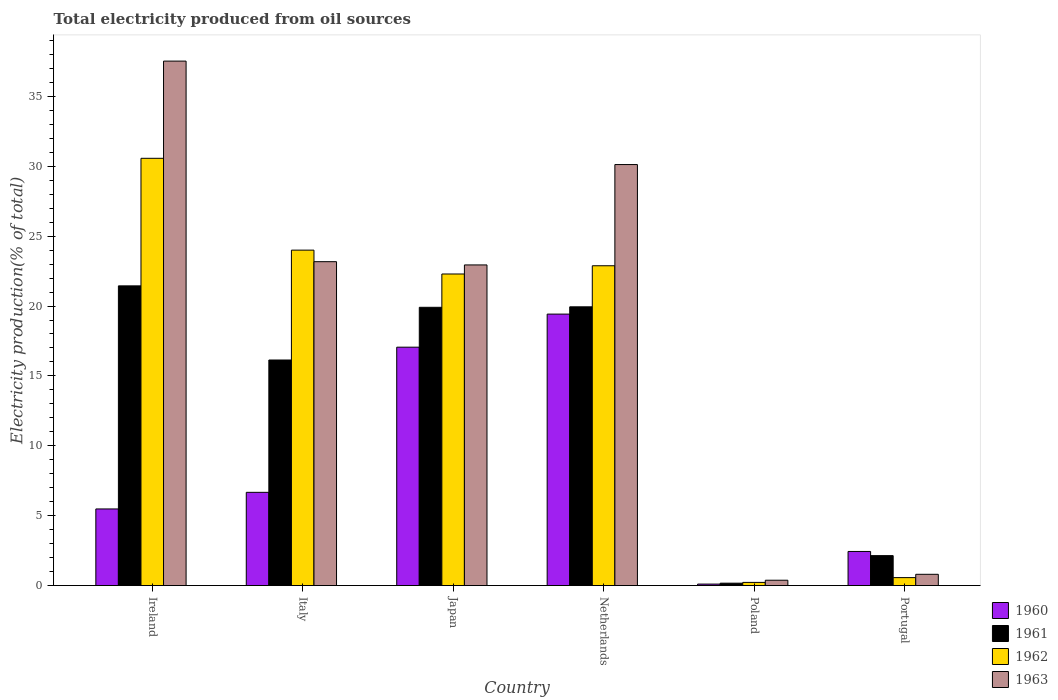How many different coloured bars are there?
Give a very brief answer. 4. Are the number of bars per tick equal to the number of legend labels?
Keep it short and to the point. Yes. Are the number of bars on each tick of the X-axis equal?
Ensure brevity in your answer.  Yes. How many bars are there on the 3rd tick from the right?
Keep it short and to the point. 4. In how many cases, is the number of bars for a given country not equal to the number of legend labels?
Your response must be concise. 0. What is the total electricity produced in 1960 in Poland?
Make the answer very short. 0.11. Across all countries, what is the maximum total electricity produced in 1960?
Provide a succinct answer. 19.42. Across all countries, what is the minimum total electricity produced in 1962?
Keep it short and to the point. 0.23. In which country was the total electricity produced in 1960 minimum?
Provide a short and direct response. Poland. What is the total total electricity produced in 1960 in the graph?
Offer a very short reply. 51.18. What is the difference between the total electricity produced in 1960 in Italy and that in Portugal?
Keep it short and to the point. 4.23. What is the difference between the total electricity produced in 1962 in Italy and the total electricity produced in 1960 in Poland?
Give a very brief answer. 23.89. What is the average total electricity produced in 1963 per country?
Give a very brief answer. 19.16. What is the difference between the total electricity produced of/in 1962 and total electricity produced of/in 1960 in Italy?
Provide a short and direct response. 17.33. What is the ratio of the total electricity produced in 1962 in Ireland to that in Poland?
Keep it short and to the point. 135.14. What is the difference between the highest and the second highest total electricity produced in 1963?
Keep it short and to the point. 7.4. What is the difference between the highest and the lowest total electricity produced in 1961?
Ensure brevity in your answer.  21.27. In how many countries, is the total electricity produced in 1963 greater than the average total electricity produced in 1963 taken over all countries?
Keep it short and to the point. 4. Is it the case that in every country, the sum of the total electricity produced in 1963 and total electricity produced in 1961 is greater than the sum of total electricity produced in 1960 and total electricity produced in 1962?
Your answer should be very brief. No. What does the 3rd bar from the left in Poland represents?
Give a very brief answer. 1962. Is it the case that in every country, the sum of the total electricity produced in 1962 and total electricity produced in 1961 is greater than the total electricity produced in 1963?
Offer a very short reply. Yes. How many bars are there?
Provide a succinct answer. 24. How many countries are there in the graph?
Offer a very short reply. 6. What is the difference between two consecutive major ticks on the Y-axis?
Make the answer very short. 5. Are the values on the major ticks of Y-axis written in scientific E-notation?
Your answer should be compact. No. Does the graph contain any zero values?
Your answer should be compact. No. Where does the legend appear in the graph?
Provide a succinct answer. Bottom right. How are the legend labels stacked?
Your response must be concise. Vertical. What is the title of the graph?
Offer a terse response. Total electricity produced from oil sources. Does "2000" appear as one of the legend labels in the graph?
Offer a very short reply. No. What is the label or title of the X-axis?
Give a very brief answer. Country. What is the Electricity production(% of total) of 1960 in Ireland?
Keep it short and to the point. 5.48. What is the Electricity production(% of total) of 1961 in Ireland?
Your response must be concise. 21.44. What is the Electricity production(% of total) in 1962 in Ireland?
Your answer should be very brief. 30.57. What is the Electricity production(% of total) of 1963 in Ireland?
Ensure brevity in your answer.  37.53. What is the Electricity production(% of total) of 1960 in Italy?
Your answer should be compact. 6.67. What is the Electricity production(% of total) of 1961 in Italy?
Offer a terse response. 16.14. What is the Electricity production(% of total) in 1962 in Italy?
Make the answer very short. 24. What is the Electricity production(% of total) of 1963 in Italy?
Provide a short and direct response. 23.17. What is the Electricity production(% of total) in 1960 in Japan?
Offer a very short reply. 17.06. What is the Electricity production(% of total) in 1961 in Japan?
Ensure brevity in your answer.  19.91. What is the Electricity production(% of total) in 1962 in Japan?
Make the answer very short. 22.29. What is the Electricity production(% of total) of 1963 in Japan?
Provide a succinct answer. 22.94. What is the Electricity production(% of total) in 1960 in Netherlands?
Provide a short and direct response. 19.42. What is the Electricity production(% of total) of 1961 in Netherlands?
Your answer should be compact. 19.94. What is the Electricity production(% of total) of 1962 in Netherlands?
Ensure brevity in your answer.  22.88. What is the Electricity production(% of total) of 1963 in Netherlands?
Provide a succinct answer. 30.12. What is the Electricity production(% of total) of 1960 in Poland?
Your answer should be compact. 0.11. What is the Electricity production(% of total) in 1961 in Poland?
Provide a short and direct response. 0.17. What is the Electricity production(% of total) of 1962 in Poland?
Your answer should be very brief. 0.23. What is the Electricity production(% of total) in 1963 in Poland?
Offer a very short reply. 0.38. What is the Electricity production(% of total) in 1960 in Portugal?
Your answer should be very brief. 2.44. What is the Electricity production(% of total) in 1961 in Portugal?
Provide a succinct answer. 2.14. What is the Electricity production(% of total) of 1962 in Portugal?
Make the answer very short. 0.57. What is the Electricity production(% of total) of 1963 in Portugal?
Give a very brief answer. 0.81. Across all countries, what is the maximum Electricity production(% of total) of 1960?
Provide a short and direct response. 19.42. Across all countries, what is the maximum Electricity production(% of total) in 1961?
Ensure brevity in your answer.  21.44. Across all countries, what is the maximum Electricity production(% of total) of 1962?
Your answer should be very brief. 30.57. Across all countries, what is the maximum Electricity production(% of total) in 1963?
Give a very brief answer. 37.53. Across all countries, what is the minimum Electricity production(% of total) in 1960?
Your answer should be very brief. 0.11. Across all countries, what is the minimum Electricity production(% of total) in 1961?
Give a very brief answer. 0.17. Across all countries, what is the minimum Electricity production(% of total) in 1962?
Offer a very short reply. 0.23. Across all countries, what is the minimum Electricity production(% of total) in 1963?
Keep it short and to the point. 0.38. What is the total Electricity production(% of total) of 1960 in the graph?
Your response must be concise. 51.18. What is the total Electricity production(% of total) in 1961 in the graph?
Your answer should be very brief. 79.75. What is the total Electricity production(% of total) of 1962 in the graph?
Your response must be concise. 100.54. What is the total Electricity production(% of total) in 1963 in the graph?
Offer a very short reply. 114.95. What is the difference between the Electricity production(% of total) of 1960 in Ireland and that in Italy?
Ensure brevity in your answer.  -1.19. What is the difference between the Electricity production(% of total) in 1961 in Ireland and that in Italy?
Your answer should be very brief. 5.3. What is the difference between the Electricity production(% of total) of 1962 in Ireland and that in Italy?
Provide a short and direct response. 6.57. What is the difference between the Electricity production(% of total) of 1963 in Ireland and that in Italy?
Keep it short and to the point. 14.35. What is the difference between the Electricity production(% of total) in 1960 in Ireland and that in Japan?
Your response must be concise. -11.57. What is the difference between the Electricity production(% of total) in 1961 in Ireland and that in Japan?
Provide a short and direct response. 1.53. What is the difference between the Electricity production(% of total) of 1962 in Ireland and that in Japan?
Your response must be concise. 8.28. What is the difference between the Electricity production(% of total) of 1963 in Ireland and that in Japan?
Ensure brevity in your answer.  14.58. What is the difference between the Electricity production(% of total) of 1960 in Ireland and that in Netherlands?
Make the answer very short. -13.94. What is the difference between the Electricity production(% of total) of 1961 in Ireland and that in Netherlands?
Make the answer very short. 1.5. What is the difference between the Electricity production(% of total) in 1962 in Ireland and that in Netherlands?
Provide a succinct answer. 7.69. What is the difference between the Electricity production(% of total) in 1963 in Ireland and that in Netherlands?
Make the answer very short. 7.4. What is the difference between the Electricity production(% of total) in 1960 in Ireland and that in Poland?
Ensure brevity in your answer.  5.38. What is the difference between the Electricity production(% of total) in 1961 in Ireland and that in Poland?
Your answer should be very brief. 21.27. What is the difference between the Electricity production(% of total) in 1962 in Ireland and that in Poland?
Your response must be concise. 30.34. What is the difference between the Electricity production(% of total) in 1963 in Ireland and that in Poland?
Keep it short and to the point. 37.14. What is the difference between the Electricity production(% of total) of 1960 in Ireland and that in Portugal?
Give a very brief answer. 3.04. What is the difference between the Electricity production(% of total) in 1961 in Ireland and that in Portugal?
Make the answer very short. 19.3. What is the difference between the Electricity production(% of total) in 1962 in Ireland and that in Portugal?
Ensure brevity in your answer.  30. What is the difference between the Electricity production(% of total) of 1963 in Ireland and that in Portugal?
Your answer should be compact. 36.72. What is the difference between the Electricity production(% of total) of 1960 in Italy and that in Japan?
Offer a terse response. -10.39. What is the difference between the Electricity production(% of total) of 1961 in Italy and that in Japan?
Offer a terse response. -3.77. What is the difference between the Electricity production(% of total) in 1962 in Italy and that in Japan?
Ensure brevity in your answer.  1.71. What is the difference between the Electricity production(% of total) of 1963 in Italy and that in Japan?
Keep it short and to the point. 0.23. What is the difference between the Electricity production(% of total) of 1960 in Italy and that in Netherlands?
Provide a short and direct response. -12.75. What is the difference between the Electricity production(% of total) in 1961 in Italy and that in Netherlands?
Your answer should be compact. -3.81. What is the difference between the Electricity production(% of total) of 1962 in Italy and that in Netherlands?
Provide a short and direct response. 1.12. What is the difference between the Electricity production(% of total) in 1963 in Italy and that in Netherlands?
Ensure brevity in your answer.  -6.95. What is the difference between the Electricity production(% of total) of 1960 in Italy and that in Poland?
Your answer should be compact. 6.57. What is the difference between the Electricity production(% of total) in 1961 in Italy and that in Poland?
Offer a terse response. 15.97. What is the difference between the Electricity production(% of total) of 1962 in Italy and that in Poland?
Provide a short and direct response. 23.77. What is the difference between the Electricity production(% of total) of 1963 in Italy and that in Poland?
Ensure brevity in your answer.  22.79. What is the difference between the Electricity production(% of total) in 1960 in Italy and that in Portugal?
Your response must be concise. 4.23. What is the difference between the Electricity production(% of total) in 1961 in Italy and that in Portugal?
Provide a short and direct response. 14. What is the difference between the Electricity production(% of total) of 1962 in Italy and that in Portugal?
Your answer should be compact. 23.43. What is the difference between the Electricity production(% of total) in 1963 in Italy and that in Portugal?
Your answer should be compact. 22.37. What is the difference between the Electricity production(% of total) in 1960 in Japan and that in Netherlands?
Ensure brevity in your answer.  -2.37. What is the difference between the Electricity production(% of total) of 1961 in Japan and that in Netherlands?
Ensure brevity in your answer.  -0.04. What is the difference between the Electricity production(% of total) in 1962 in Japan and that in Netherlands?
Provide a succinct answer. -0.59. What is the difference between the Electricity production(% of total) of 1963 in Japan and that in Netherlands?
Provide a short and direct response. -7.18. What is the difference between the Electricity production(% of total) in 1960 in Japan and that in Poland?
Your answer should be compact. 16.95. What is the difference between the Electricity production(% of total) in 1961 in Japan and that in Poland?
Your answer should be very brief. 19.74. What is the difference between the Electricity production(% of total) in 1962 in Japan and that in Poland?
Give a very brief answer. 22.07. What is the difference between the Electricity production(% of total) in 1963 in Japan and that in Poland?
Offer a terse response. 22.56. What is the difference between the Electricity production(% of total) in 1960 in Japan and that in Portugal?
Give a very brief answer. 14.62. What is the difference between the Electricity production(% of total) of 1961 in Japan and that in Portugal?
Make the answer very short. 17.77. What is the difference between the Electricity production(% of total) in 1962 in Japan and that in Portugal?
Provide a short and direct response. 21.73. What is the difference between the Electricity production(% of total) of 1963 in Japan and that in Portugal?
Ensure brevity in your answer.  22.14. What is the difference between the Electricity production(% of total) in 1960 in Netherlands and that in Poland?
Your response must be concise. 19.32. What is the difference between the Electricity production(% of total) of 1961 in Netherlands and that in Poland?
Your response must be concise. 19.77. What is the difference between the Electricity production(% of total) in 1962 in Netherlands and that in Poland?
Provide a succinct answer. 22.66. What is the difference between the Electricity production(% of total) in 1963 in Netherlands and that in Poland?
Ensure brevity in your answer.  29.74. What is the difference between the Electricity production(% of total) of 1960 in Netherlands and that in Portugal?
Your response must be concise. 16.98. What is the difference between the Electricity production(% of total) of 1961 in Netherlands and that in Portugal?
Your answer should be very brief. 17.8. What is the difference between the Electricity production(% of total) of 1962 in Netherlands and that in Portugal?
Keep it short and to the point. 22.31. What is the difference between the Electricity production(% of total) in 1963 in Netherlands and that in Portugal?
Your response must be concise. 29.32. What is the difference between the Electricity production(% of total) in 1960 in Poland and that in Portugal?
Your response must be concise. -2.33. What is the difference between the Electricity production(% of total) of 1961 in Poland and that in Portugal?
Your answer should be very brief. -1.97. What is the difference between the Electricity production(% of total) in 1962 in Poland and that in Portugal?
Offer a terse response. -0.34. What is the difference between the Electricity production(% of total) in 1963 in Poland and that in Portugal?
Give a very brief answer. -0.42. What is the difference between the Electricity production(% of total) of 1960 in Ireland and the Electricity production(% of total) of 1961 in Italy?
Offer a terse response. -10.66. What is the difference between the Electricity production(% of total) of 1960 in Ireland and the Electricity production(% of total) of 1962 in Italy?
Your response must be concise. -18.52. What is the difference between the Electricity production(% of total) of 1960 in Ireland and the Electricity production(% of total) of 1963 in Italy?
Make the answer very short. -17.69. What is the difference between the Electricity production(% of total) in 1961 in Ireland and the Electricity production(% of total) in 1962 in Italy?
Provide a short and direct response. -2.56. What is the difference between the Electricity production(% of total) in 1961 in Ireland and the Electricity production(% of total) in 1963 in Italy?
Provide a short and direct response. -1.73. What is the difference between the Electricity production(% of total) of 1962 in Ireland and the Electricity production(% of total) of 1963 in Italy?
Keep it short and to the point. 7.4. What is the difference between the Electricity production(% of total) of 1960 in Ireland and the Electricity production(% of total) of 1961 in Japan?
Provide a succinct answer. -14.43. What is the difference between the Electricity production(% of total) in 1960 in Ireland and the Electricity production(% of total) in 1962 in Japan?
Ensure brevity in your answer.  -16.81. What is the difference between the Electricity production(% of total) in 1960 in Ireland and the Electricity production(% of total) in 1963 in Japan?
Provide a short and direct response. -17.46. What is the difference between the Electricity production(% of total) of 1961 in Ireland and the Electricity production(% of total) of 1962 in Japan?
Give a very brief answer. -0.85. What is the difference between the Electricity production(% of total) in 1961 in Ireland and the Electricity production(% of total) in 1963 in Japan?
Give a very brief answer. -1.5. What is the difference between the Electricity production(% of total) in 1962 in Ireland and the Electricity production(% of total) in 1963 in Japan?
Your answer should be very brief. 7.63. What is the difference between the Electricity production(% of total) in 1960 in Ireland and the Electricity production(% of total) in 1961 in Netherlands?
Your answer should be compact. -14.46. What is the difference between the Electricity production(% of total) of 1960 in Ireland and the Electricity production(% of total) of 1962 in Netherlands?
Give a very brief answer. -17.4. What is the difference between the Electricity production(% of total) in 1960 in Ireland and the Electricity production(% of total) in 1963 in Netherlands?
Keep it short and to the point. -24.64. What is the difference between the Electricity production(% of total) in 1961 in Ireland and the Electricity production(% of total) in 1962 in Netherlands?
Give a very brief answer. -1.44. What is the difference between the Electricity production(% of total) in 1961 in Ireland and the Electricity production(% of total) in 1963 in Netherlands?
Your response must be concise. -8.68. What is the difference between the Electricity production(% of total) of 1962 in Ireland and the Electricity production(% of total) of 1963 in Netherlands?
Give a very brief answer. 0.45. What is the difference between the Electricity production(% of total) in 1960 in Ireland and the Electricity production(% of total) in 1961 in Poland?
Make the answer very short. 5.31. What is the difference between the Electricity production(% of total) in 1960 in Ireland and the Electricity production(% of total) in 1962 in Poland?
Your answer should be very brief. 5.26. What is the difference between the Electricity production(% of total) in 1960 in Ireland and the Electricity production(% of total) in 1963 in Poland?
Provide a succinct answer. 5.1. What is the difference between the Electricity production(% of total) of 1961 in Ireland and the Electricity production(% of total) of 1962 in Poland?
Make the answer very short. 21.22. What is the difference between the Electricity production(% of total) of 1961 in Ireland and the Electricity production(% of total) of 1963 in Poland?
Ensure brevity in your answer.  21.06. What is the difference between the Electricity production(% of total) in 1962 in Ireland and the Electricity production(% of total) in 1963 in Poland?
Your answer should be very brief. 30.19. What is the difference between the Electricity production(% of total) in 1960 in Ireland and the Electricity production(% of total) in 1961 in Portugal?
Provide a short and direct response. 3.34. What is the difference between the Electricity production(% of total) in 1960 in Ireland and the Electricity production(% of total) in 1962 in Portugal?
Your answer should be compact. 4.91. What is the difference between the Electricity production(% of total) in 1960 in Ireland and the Electricity production(% of total) in 1963 in Portugal?
Make the answer very short. 4.68. What is the difference between the Electricity production(% of total) in 1961 in Ireland and the Electricity production(% of total) in 1962 in Portugal?
Your response must be concise. 20.87. What is the difference between the Electricity production(% of total) in 1961 in Ireland and the Electricity production(% of total) in 1963 in Portugal?
Make the answer very short. 20.64. What is the difference between the Electricity production(% of total) of 1962 in Ireland and the Electricity production(% of total) of 1963 in Portugal?
Ensure brevity in your answer.  29.77. What is the difference between the Electricity production(% of total) of 1960 in Italy and the Electricity production(% of total) of 1961 in Japan?
Make the answer very short. -13.24. What is the difference between the Electricity production(% of total) of 1960 in Italy and the Electricity production(% of total) of 1962 in Japan?
Keep it short and to the point. -15.62. What is the difference between the Electricity production(% of total) of 1960 in Italy and the Electricity production(% of total) of 1963 in Japan?
Keep it short and to the point. -16.27. What is the difference between the Electricity production(% of total) in 1961 in Italy and the Electricity production(% of total) in 1962 in Japan?
Ensure brevity in your answer.  -6.15. What is the difference between the Electricity production(% of total) of 1961 in Italy and the Electricity production(% of total) of 1963 in Japan?
Make the answer very short. -6.8. What is the difference between the Electricity production(% of total) in 1962 in Italy and the Electricity production(% of total) in 1963 in Japan?
Ensure brevity in your answer.  1.06. What is the difference between the Electricity production(% of total) of 1960 in Italy and the Electricity production(% of total) of 1961 in Netherlands?
Offer a very short reply. -13.27. What is the difference between the Electricity production(% of total) of 1960 in Italy and the Electricity production(% of total) of 1962 in Netherlands?
Give a very brief answer. -16.21. What is the difference between the Electricity production(% of total) of 1960 in Italy and the Electricity production(% of total) of 1963 in Netherlands?
Your answer should be compact. -23.45. What is the difference between the Electricity production(% of total) of 1961 in Italy and the Electricity production(% of total) of 1962 in Netherlands?
Provide a short and direct response. -6.74. What is the difference between the Electricity production(% of total) of 1961 in Italy and the Electricity production(% of total) of 1963 in Netherlands?
Give a very brief answer. -13.98. What is the difference between the Electricity production(% of total) in 1962 in Italy and the Electricity production(% of total) in 1963 in Netherlands?
Make the answer very short. -6.12. What is the difference between the Electricity production(% of total) of 1960 in Italy and the Electricity production(% of total) of 1961 in Poland?
Your answer should be compact. 6.5. What is the difference between the Electricity production(% of total) of 1960 in Italy and the Electricity production(% of total) of 1962 in Poland?
Your answer should be very brief. 6.44. What is the difference between the Electricity production(% of total) in 1960 in Italy and the Electricity production(% of total) in 1963 in Poland?
Give a very brief answer. 6.29. What is the difference between the Electricity production(% of total) in 1961 in Italy and the Electricity production(% of total) in 1962 in Poland?
Make the answer very short. 15.91. What is the difference between the Electricity production(% of total) of 1961 in Italy and the Electricity production(% of total) of 1963 in Poland?
Your answer should be very brief. 15.76. What is the difference between the Electricity production(% of total) in 1962 in Italy and the Electricity production(% of total) in 1963 in Poland?
Ensure brevity in your answer.  23.62. What is the difference between the Electricity production(% of total) of 1960 in Italy and the Electricity production(% of total) of 1961 in Portugal?
Your answer should be compact. 4.53. What is the difference between the Electricity production(% of total) of 1960 in Italy and the Electricity production(% of total) of 1962 in Portugal?
Your answer should be very brief. 6.1. What is the difference between the Electricity production(% of total) in 1960 in Italy and the Electricity production(% of total) in 1963 in Portugal?
Offer a terse response. 5.87. What is the difference between the Electricity production(% of total) of 1961 in Italy and the Electricity production(% of total) of 1962 in Portugal?
Your response must be concise. 15.57. What is the difference between the Electricity production(% of total) in 1961 in Italy and the Electricity production(% of total) in 1963 in Portugal?
Provide a succinct answer. 15.33. What is the difference between the Electricity production(% of total) in 1962 in Italy and the Electricity production(% of total) in 1963 in Portugal?
Offer a very short reply. 23.19. What is the difference between the Electricity production(% of total) in 1960 in Japan and the Electricity production(% of total) in 1961 in Netherlands?
Offer a very short reply. -2.89. What is the difference between the Electricity production(% of total) of 1960 in Japan and the Electricity production(% of total) of 1962 in Netherlands?
Provide a short and direct response. -5.83. What is the difference between the Electricity production(% of total) in 1960 in Japan and the Electricity production(% of total) in 1963 in Netherlands?
Give a very brief answer. -13.07. What is the difference between the Electricity production(% of total) in 1961 in Japan and the Electricity production(% of total) in 1962 in Netherlands?
Make the answer very short. -2.97. What is the difference between the Electricity production(% of total) in 1961 in Japan and the Electricity production(% of total) in 1963 in Netherlands?
Your answer should be very brief. -10.21. What is the difference between the Electricity production(% of total) in 1962 in Japan and the Electricity production(% of total) in 1963 in Netherlands?
Offer a very short reply. -7.83. What is the difference between the Electricity production(% of total) in 1960 in Japan and the Electricity production(% of total) in 1961 in Poland?
Provide a succinct answer. 16.89. What is the difference between the Electricity production(% of total) in 1960 in Japan and the Electricity production(% of total) in 1962 in Poland?
Give a very brief answer. 16.83. What is the difference between the Electricity production(% of total) in 1960 in Japan and the Electricity production(% of total) in 1963 in Poland?
Offer a very short reply. 16.67. What is the difference between the Electricity production(% of total) of 1961 in Japan and the Electricity production(% of total) of 1962 in Poland?
Keep it short and to the point. 19.68. What is the difference between the Electricity production(% of total) in 1961 in Japan and the Electricity production(% of total) in 1963 in Poland?
Offer a very short reply. 19.53. What is the difference between the Electricity production(% of total) of 1962 in Japan and the Electricity production(% of total) of 1963 in Poland?
Make the answer very short. 21.91. What is the difference between the Electricity production(% of total) of 1960 in Japan and the Electricity production(% of total) of 1961 in Portugal?
Your answer should be very brief. 14.91. What is the difference between the Electricity production(% of total) of 1960 in Japan and the Electricity production(% of total) of 1962 in Portugal?
Offer a terse response. 16.49. What is the difference between the Electricity production(% of total) in 1960 in Japan and the Electricity production(% of total) in 1963 in Portugal?
Give a very brief answer. 16.25. What is the difference between the Electricity production(% of total) of 1961 in Japan and the Electricity production(% of total) of 1962 in Portugal?
Give a very brief answer. 19.34. What is the difference between the Electricity production(% of total) of 1961 in Japan and the Electricity production(% of total) of 1963 in Portugal?
Offer a very short reply. 19.1. What is the difference between the Electricity production(% of total) in 1962 in Japan and the Electricity production(% of total) in 1963 in Portugal?
Offer a terse response. 21.49. What is the difference between the Electricity production(% of total) in 1960 in Netherlands and the Electricity production(% of total) in 1961 in Poland?
Ensure brevity in your answer.  19.25. What is the difference between the Electricity production(% of total) of 1960 in Netherlands and the Electricity production(% of total) of 1962 in Poland?
Make the answer very short. 19.2. What is the difference between the Electricity production(% of total) of 1960 in Netherlands and the Electricity production(% of total) of 1963 in Poland?
Make the answer very short. 19.04. What is the difference between the Electricity production(% of total) of 1961 in Netherlands and the Electricity production(% of total) of 1962 in Poland?
Keep it short and to the point. 19.72. What is the difference between the Electricity production(% of total) of 1961 in Netherlands and the Electricity production(% of total) of 1963 in Poland?
Your answer should be compact. 19.56. What is the difference between the Electricity production(% of total) in 1962 in Netherlands and the Electricity production(% of total) in 1963 in Poland?
Provide a succinct answer. 22.5. What is the difference between the Electricity production(% of total) of 1960 in Netherlands and the Electricity production(% of total) of 1961 in Portugal?
Your answer should be compact. 17.28. What is the difference between the Electricity production(% of total) of 1960 in Netherlands and the Electricity production(% of total) of 1962 in Portugal?
Make the answer very short. 18.86. What is the difference between the Electricity production(% of total) of 1960 in Netherlands and the Electricity production(% of total) of 1963 in Portugal?
Your answer should be very brief. 18.62. What is the difference between the Electricity production(% of total) of 1961 in Netherlands and the Electricity production(% of total) of 1962 in Portugal?
Offer a terse response. 19.38. What is the difference between the Electricity production(% of total) in 1961 in Netherlands and the Electricity production(% of total) in 1963 in Portugal?
Ensure brevity in your answer.  19.14. What is the difference between the Electricity production(% of total) in 1962 in Netherlands and the Electricity production(% of total) in 1963 in Portugal?
Offer a terse response. 22.08. What is the difference between the Electricity production(% of total) of 1960 in Poland and the Electricity production(% of total) of 1961 in Portugal?
Offer a very short reply. -2.04. What is the difference between the Electricity production(% of total) in 1960 in Poland and the Electricity production(% of total) in 1962 in Portugal?
Offer a very short reply. -0.46. What is the difference between the Electricity production(% of total) in 1960 in Poland and the Electricity production(% of total) in 1963 in Portugal?
Your answer should be compact. -0.7. What is the difference between the Electricity production(% of total) of 1961 in Poland and the Electricity production(% of total) of 1962 in Portugal?
Your answer should be compact. -0.4. What is the difference between the Electricity production(% of total) in 1961 in Poland and the Electricity production(% of total) in 1963 in Portugal?
Make the answer very short. -0.63. What is the difference between the Electricity production(% of total) in 1962 in Poland and the Electricity production(% of total) in 1963 in Portugal?
Your answer should be very brief. -0.58. What is the average Electricity production(% of total) of 1960 per country?
Provide a short and direct response. 8.53. What is the average Electricity production(% of total) of 1961 per country?
Your response must be concise. 13.29. What is the average Electricity production(% of total) in 1962 per country?
Your response must be concise. 16.76. What is the average Electricity production(% of total) of 1963 per country?
Make the answer very short. 19.16. What is the difference between the Electricity production(% of total) of 1960 and Electricity production(% of total) of 1961 in Ireland?
Ensure brevity in your answer.  -15.96. What is the difference between the Electricity production(% of total) of 1960 and Electricity production(% of total) of 1962 in Ireland?
Ensure brevity in your answer.  -25.09. What is the difference between the Electricity production(% of total) of 1960 and Electricity production(% of total) of 1963 in Ireland?
Make the answer very short. -32.04. What is the difference between the Electricity production(% of total) of 1961 and Electricity production(% of total) of 1962 in Ireland?
Offer a very short reply. -9.13. What is the difference between the Electricity production(% of total) of 1961 and Electricity production(% of total) of 1963 in Ireland?
Give a very brief answer. -16.08. What is the difference between the Electricity production(% of total) in 1962 and Electricity production(% of total) in 1963 in Ireland?
Your answer should be very brief. -6.95. What is the difference between the Electricity production(% of total) of 1960 and Electricity production(% of total) of 1961 in Italy?
Provide a succinct answer. -9.47. What is the difference between the Electricity production(% of total) of 1960 and Electricity production(% of total) of 1962 in Italy?
Provide a short and direct response. -17.33. What is the difference between the Electricity production(% of total) of 1960 and Electricity production(% of total) of 1963 in Italy?
Ensure brevity in your answer.  -16.5. What is the difference between the Electricity production(% of total) in 1961 and Electricity production(% of total) in 1962 in Italy?
Offer a very short reply. -7.86. What is the difference between the Electricity production(% of total) of 1961 and Electricity production(% of total) of 1963 in Italy?
Keep it short and to the point. -7.04. What is the difference between the Electricity production(% of total) of 1962 and Electricity production(% of total) of 1963 in Italy?
Provide a short and direct response. 0.83. What is the difference between the Electricity production(% of total) in 1960 and Electricity production(% of total) in 1961 in Japan?
Provide a short and direct response. -2.85. What is the difference between the Electricity production(% of total) of 1960 and Electricity production(% of total) of 1962 in Japan?
Your answer should be very brief. -5.24. What is the difference between the Electricity production(% of total) in 1960 and Electricity production(% of total) in 1963 in Japan?
Keep it short and to the point. -5.89. What is the difference between the Electricity production(% of total) in 1961 and Electricity production(% of total) in 1962 in Japan?
Offer a terse response. -2.38. What is the difference between the Electricity production(% of total) in 1961 and Electricity production(% of total) in 1963 in Japan?
Keep it short and to the point. -3.03. What is the difference between the Electricity production(% of total) of 1962 and Electricity production(% of total) of 1963 in Japan?
Your answer should be very brief. -0.65. What is the difference between the Electricity production(% of total) of 1960 and Electricity production(% of total) of 1961 in Netherlands?
Offer a very short reply. -0.52. What is the difference between the Electricity production(% of total) of 1960 and Electricity production(% of total) of 1962 in Netherlands?
Provide a short and direct response. -3.46. What is the difference between the Electricity production(% of total) of 1960 and Electricity production(% of total) of 1963 in Netherlands?
Give a very brief answer. -10.7. What is the difference between the Electricity production(% of total) in 1961 and Electricity production(% of total) in 1962 in Netherlands?
Make the answer very short. -2.94. What is the difference between the Electricity production(% of total) in 1961 and Electricity production(% of total) in 1963 in Netherlands?
Keep it short and to the point. -10.18. What is the difference between the Electricity production(% of total) in 1962 and Electricity production(% of total) in 1963 in Netherlands?
Provide a succinct answer. -7.24. What is the difference between the Electricity production(% of total) in 1960 and Electricity production(% of total) in 1961 in Poland?
Offer a terse response. -0.06. What is the difference between the Electricity production(% of total) in 1960 and Electricity production(% of total) in 1962 in Poland?
Offer a very short reply. -0.12. What is the difference between the Electricity production(% of total) in 1960 and Electricity production(% of total) in 1963 in Poland?
Provide a succinct answer. -0.28. What is the difference between the Electricity production(% of total) of 1961 and Electricity production(% of total) of 1962 in Poland?
Provide a short and direct response. -0.06. What is the difference between the Electricity production(% of total) in 1961 and Electricity production(% of total) in 1963 in Poland?
Your response must be concise. -0.21. What is the difference between the Electricity production(% of total) in 1962 and Electricity production(% of total) in 1963 in Poland?
Provide a short and direct response. -0.16. What is the difference between the Electricity production(% of total) in 1960 and Electricity production(% of total) in 1961 in Portugal?
Ensure brevity in your answer.  0.3. What is the difference between the Electricity production(% of total) of 1960 and Electricity production(% of total) of 1962 in Portugal?
Provide a short and direct response. 1.87. What is the difference between the Electricity production(% of total) in 1960 and Electricity production(% of total) in 1963 in Portugal?
Provide a succinct answer. 1.63. What is the difference between the Electricity production(% of total) of 1961 and Electricity production(% of total) of 1962 in Portugal?
Provide a short and direct response. 1.57. What is the difference between the Electricity production(% of total) of 1961 and Electricity production(% of total) of 1963 in Portugal?
Your response must be concise. 1.34. What is the difference between the Electricity production(% of total) of 1962 and Electricity production(% of total) of 1963 in Portugal?
Your answer should be compact. -0.24. What is the ratio of the Electricity production(% of total) in 1960 in Ireland to that in Italy?
Make the answer very short. 0.82. What is the ratio of the Electricity production(% of total) of 1961 in Ireland to that in Italy?
Give a very brief answer. 1.33. What is the ratio of the Electricity production(% of total) in 1962 in Ireland to that in Italy?
Ensure brevity in your answer.  1.27. What is the ratio of the Electricity production(% of total) in 1963 in Ireland to that in Italy?
Provide a short and direct response. 1.62. What is the ratio of the Electricity production(% of total) in 1960 in Ireland to that in Japan?
Provide a succinct answer. 0.32. What is the ratio of the Electricity production(% of total) in 1961 in Ireland to that in Japan?
Provide a short and direct response. 1.08. What is the ratio of the Electricity production(% of total) in 1962 in Ireland to that in Japan?
Offer a terse response. 1.37. What is the ratio of the Electricity production(% of total) of 1963 in Ireland to that in Japan?
Ensure brevity in your answer.  1.64. What is the ratio of the Electricity production(% of total) in 1960 in Ireland to that in Netherlands?
Provide a succinct answer. 0.28. What is the ratio of the Electricity production(% of total) in 1961 in Ireland to that in Netherlands?
Your answer should be very brief. 1.08. What is the ratio of the Electricity production(% of total) of 1962 in Ireland to that in Netherlands?
Your response must be concise. 1.34. What is the ratio of the Electricity production(% of total) in 1963 in Ireland to that in Netherlands?
Your response must be concise. 1.25. What is the ratio of the Electricity production(% of total) in 1960 in Ireland to that in Poland?
Offer a very short reply. 51.78. What is the ratio of the Electricity production(% of total) in 1961 in Ireland to that in Poland?
Offer a terse response. 125.7. What is the ratio of the Electricity production(% of total) of 1962 in Ireland to that in Poland?
Your answer should be compact. 135.14. What is the ratio of the Electricity production(% of total) of 1963 in Ireland to that in Poland?
Your response must be concise. 98.31. What is the ratio of the Electricity production(% of total) in 1960 in Ireland to that in Portugal?
Your response must be concise. 2.25. What is the ratio of the Electricity production(% of total) in 1961 in Ireland to that in Portugal?
Keep it short and to the point. 10.01. What is the ratio of the Electricity production(% of total) in 1962 in Ireland to that in Portugal?
Make the answer very short. 53.8. What is the ratio of the Electricity production(% of total) of 1963 in Ireland to that in Portugal?
Provide a short and direct response. 46.6. What is the ratio of the Electricity production(% of total) of 1960 in Italy to that in Japan?
Make the answer very short. 0.39. What is the ratio of the Electricity production(% of total) in 1961 in Italy to that in Japan?
Offer a very short reply. 0.81. What is the ratio of the Electricity production(% of total) in 1962 in Italy to that in Japan?
Your answer should be very brief. 1.08. What is the ratio of the Electricity production(% of total) of 1960 in Italy to that in Netherlands?
Your answer should be very brief. 0.34. What is the ratio of the Electricity production(% of total) of 1961 in Italy to that in Netherlands?
Your answer should be compact. 0.81. What is the ratio of the Electricity production(% of total) of 1962 in Italy to that in Netherlands?
Provide a succinct answer. 1.05. What is the ratio of the Electricity production(% of total) in 1963 in Italy to that in Netherlands?
Give a very brief answer. 0.77. What is the ratio of the Electricity production(% of total) of 1960 in Italy to that in Poland?
Your response must be concise. 63.01. What is the ratio of the Electricity production(% of total) of 1961 in Italy to that in Poland?
Ensure brevity in your answer.  94.6. What is the ratio of the Electricity production(% of total) in 1962 in Italy to that in Poland?
Your answer should be compact. 106.09. What is the ratio of the Electricity production(% of total) in 1963 in Italy to that in Poland?
Provide a succinct answer. 60.72. What is the ratio of the Electricity production(% of total) in 1960 in Italy to that in Portugal?
Make the answer very short. 2.73. What is the ratio of the Electricity production(% of total) of 1961 in Italy to that in Portugal?
Your response must be concise. 7.54. What is the ratio of the Electricity production(% of total) in 1962 in Italy to that in Portugal?
Provide a short and direct response. 42.24. What is the ratio of the Electricity production(% of total) in 1963 in Italy to that in Portugal?
Provide a short and direct response. 28.78. What is the ratio of the Electricity production(% of total) of 1960 in Japan to that in Netherlands?
Your response must be concise. 0.88. What is the ratio of the Electricity production(% of total) in 1961 in Japan to that in Netherlands?
Ensure brevity in your answer.  1. What is the ratio of the Electricity production(% of total) of 1962 in Japan to that in Netherlands?
Provide a succinct answer. 0.97. What is the ratio of the Electricity production(% of total) in 1963 in Japan to that in Netherlands?
Your response must be concise. 0.76. What is the ratio of the Electricity production(% of total) of 1960 in Japan to that in Poland?
Your answer should be very brief. 161.11. What is the ratio of the Electricity production(% of total) in 1961 in Japan to that in Poland?
Keep it short and to the point. 116.7. What is the ratio of the Electricity production(% of total) in 1962 in Japan to that in Poland?
Keep it short and to the point. 98.55. What is the ratio of the Electricity production(% of total) in 1963 in Japan to that in Poland?
Offer a very short reply. 60.11. What is the ratio of the Electricity production(% of total) of 1960 in Japan to that in Portugal?
Your answer should be compact. 6.99. What is the ratio of the Electricity production(% of total) of 1961 in Japan to that in Portugal?
Your answer should be very brief. 9.3. What is the ratio of the Electricity production(% of total) of 1962 in Japan to that in Portugal?
Your answer should be very brief. 39.24. What is the ratio of the Electricity production(% of total) in 1963 in Japan to that in Portugal?
Your answer should be very brief. 28.49. What is the ratio of the Electricity production(% of total) in 1960 in Netherlands to that in Poland?
Offer a terse response. 183.47. What is the ratio of the Electricity production(% of total) in 1961 in Netherlands to that in Poland?
Provide a short and direct response. 116.91. What is the ratio of the Electricity production(% of total) of 1962 in Netherlands to that in Poland?
Provide a short and direct response. 101.15. What is the ratio of the Electricity production(% of total) in 1963 in Netherlands to that in Poland?
Your response must be concise. 78.92. What is the ratio of the Electricity production(% of total) in 1960 in Netherlands to that in Portugal?
Offer a very short reply. 7.96. What is the ratio of the Electricity production(% of total) in 1961 in Netherlands to that in Portugal?
Your answer should be very brief. 9.31. What is the ratio of the Electricity production(% of total) of 1962 in Netherlands to that in Portugal?
Give a very brief answer. 40.27. What is the ratio of the Electricity production(% of total) in 1963 in Netherlands to that in Portugal?
Make the answer very short. 37.4. What is the ratio of the Electricity production(% of total) in 1960 in Poland to that in Portugal?
Your answer should be compact. 0.04. What is the ratio of the Electricity production(% of total) of 1961 in Poland to that in Portugal?
Keep it short and to the point. 0.08. What is the ratio of the Electricity production(% of total) in 1962 in Poland to that in Portugal?
Give a very brief answer. 0.4. What is the ratio of the Electricity production(% of total) in 1963 in Poland to that in Portugal?
Offer a very short reply. 0.47. What is the difference between the highest and the second highest Electricity production(% of total) of 1960?
Your answer should be compact. 2.37. What is the difference between the highest and the second highest Electricity production(% of total) of 1961?
Your answer should be very brief. 1.5. What is the difference between the highest and the second highest Electricity production(% of total) in 1962?
Provide a short and direct response. 6.57. What is the difference between the highest and the second highest Electricity production(% of total) in 1963?
Your answer should be very brief. 7.4. What is the difference between the highest and the lowest Electricity production(% of total) of 1960?
Offer a terse response. 19.32. What is the difference between the highest and the lowest Electricity production(% of total) of 1961?
Ensure brevity in your answer.  21.27. What is the difference between the highest and the lowest Electricity production(% of total) in 1962?
Provide a short and direct response. 30.34. What is the difference between the highest and the lowest Electricity production(% of total) of 1963?
Your answer should be compact. 37.14. 